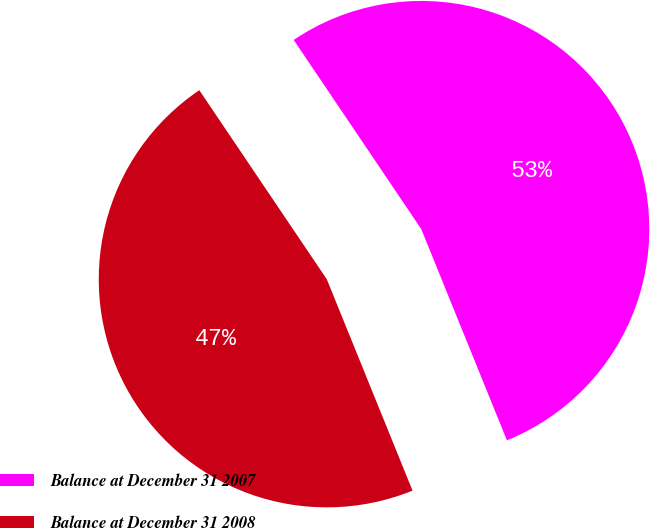Convert chart to OTSL. <chart><loc_0><loc_0><loc_500><loc_500><pie_chart><fcel>Balance at December 31 2007<fcel>Balance at December 31 2008<nl><fcel>53.31%<fcel>46.69%<nl></chart> 